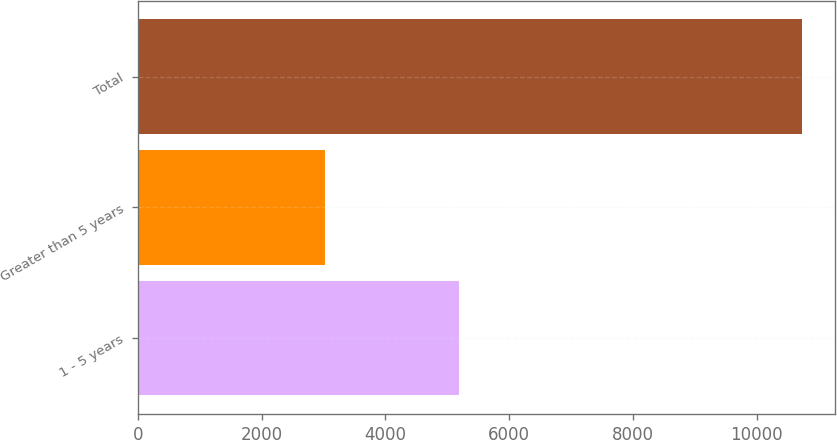Convert chart to OTSL. <chart><loc_0><loc_0><loc_500><loc_500><bar_chart><fcel>1 - 5 years<fcel>Greater than 5 years<fcel>Total<nl><fcel>5192<fcel>3028<fcel>10726<nl></chart> 